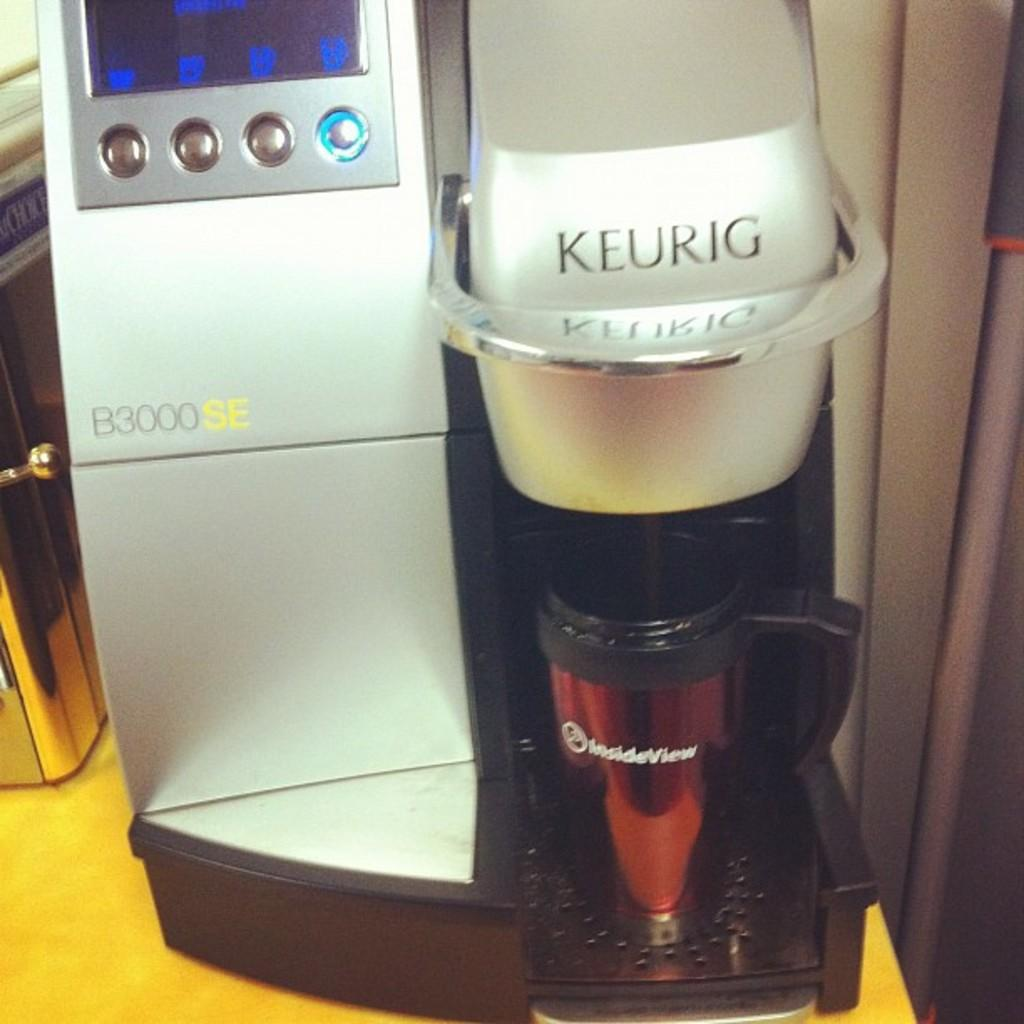<image>
Offer a succinct explanation of the picture presented. a keurig b300se coffee maker, with a mug in the slot 